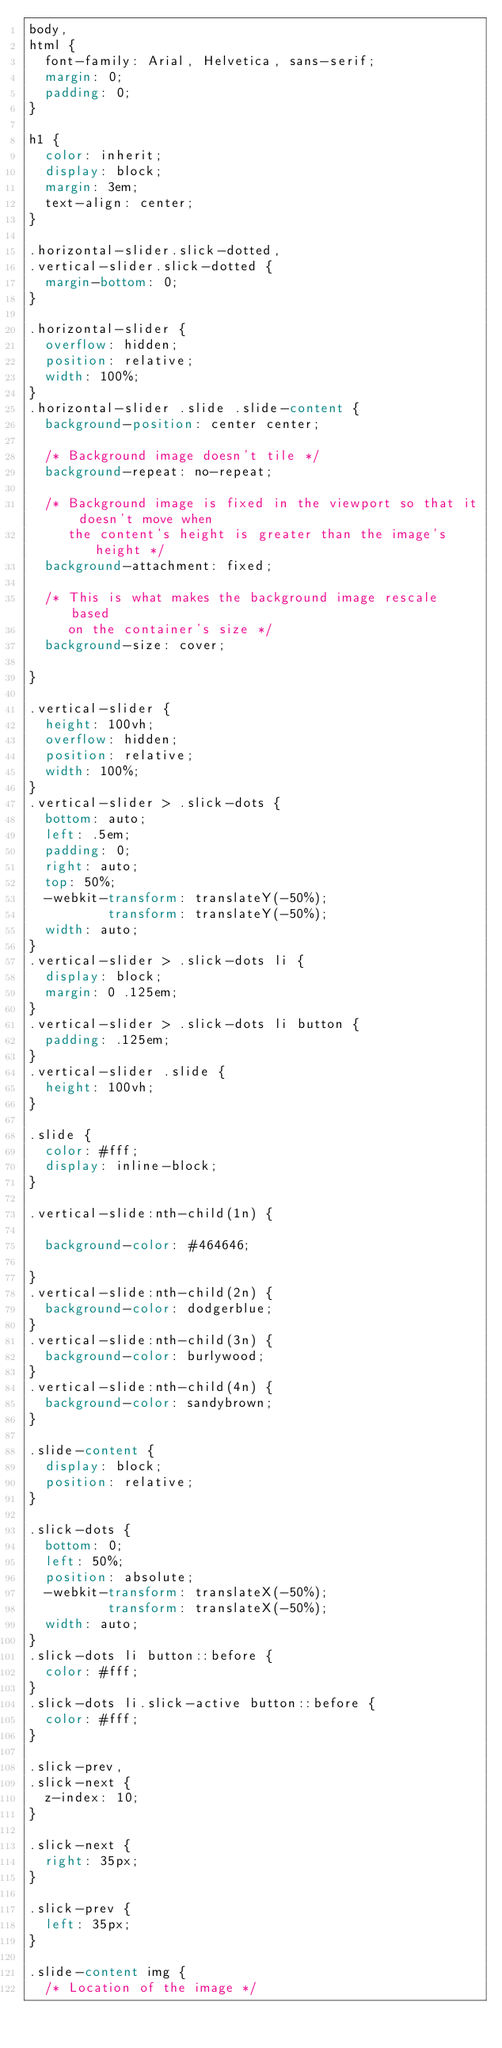Convert code to text. <code><loc_0><loc_0><loc_500><loc_500><_CSS_>body,
html {
  font-family: Arial, Helvetica, sans-serif;
  margin: 0;
  padding: 0;
}

h1 {
  color: inherit;
  display: block;
  margin: 3em;
  text-align: center;
}

.horizontal-slider.slick-dotted,
.vertical-slider.slick-dotted {
  margin-bottom: 0;
}

.horizontal-slider {
  overflow: hidden;
  position: relative;
  width: 100%;
}
.horizontal-slider .slide .slide-content {
  background-position: center center;

  /* Background image doesn't tile */
  background-repeat: no-repeat;

  /* Background image is fixed in the viewport so that it doesn't move when
     the content's height is greater than the image's height */
  background-attachment: fixed;

  /* This is what makes the background image rescale based
     on the container's size */
  background-size: cover;

}

.vertical-slider {
  height: 100vh;
  overflow: hidden;
  position: relative;
  width: 100%;
}
.vertical-slider > .slick-dots {
  bottom: auto;
  left: .5em;
  padding: 0;
  right: auto;
  top: 50%;
  -webkit-transform: translateY(-50%);
          transform: translateY(-50%);
  width: auto;
}
.vertical-slider > .slick-dots li {
  display: block;
  margin: 0 .125em;
}
.vertical-slider > .slick-dots li button {
  padding: .125em;
}
.vertical-slider .slide {
  height: 100vh;
}

.slide {
  color: #fff;
  display: inline-block;
}

.vertical-slide:nth-child(1n) {

  background-color: #464646;

}
.vertical-slide:nth-child(2n) {
  background-color: dodgerblue;
}
.vertical-slide:nth-child(3n) {
  background-color: burlywood;
}
.vertical-slide:nth-child(4n) {
  background-color: sandybrown;
}

.slide-content {
  display: block;
  position: relative;
}

.slick-dots {
  bottom: 0;
  left: 50%;
  position: absolute;
  -webkit-transform: translateX(-50%);
          transform: translateX(-50%);
  width: auto;
}
.slick-dots li button::before {
  color: #fff;
}
.slick-dots li.slick-active button::before {
  color: #fff;
}

.slick-prev,
.slick-next {
  z-index: 10;
}

.slick-next {
  right: 35px;
}

.slick-prev {
  left: 35px;
}

.slide-content img {
  /* Location of the image */</code> 